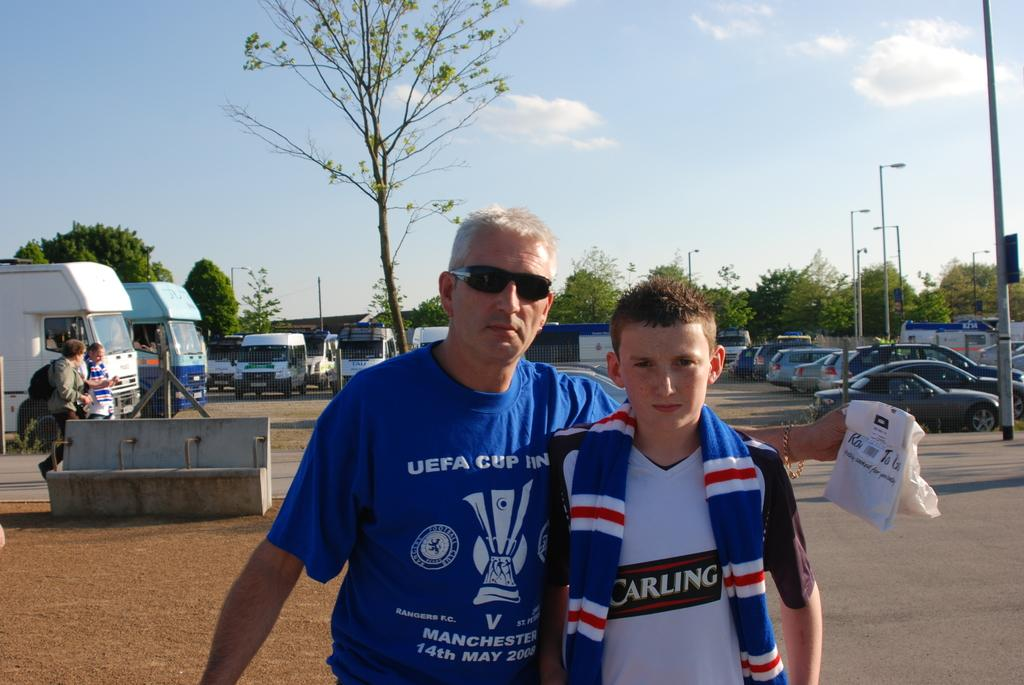<image>
Describe the image concisely. The man has a UEFA shirt on which represents the European Soccer League. 